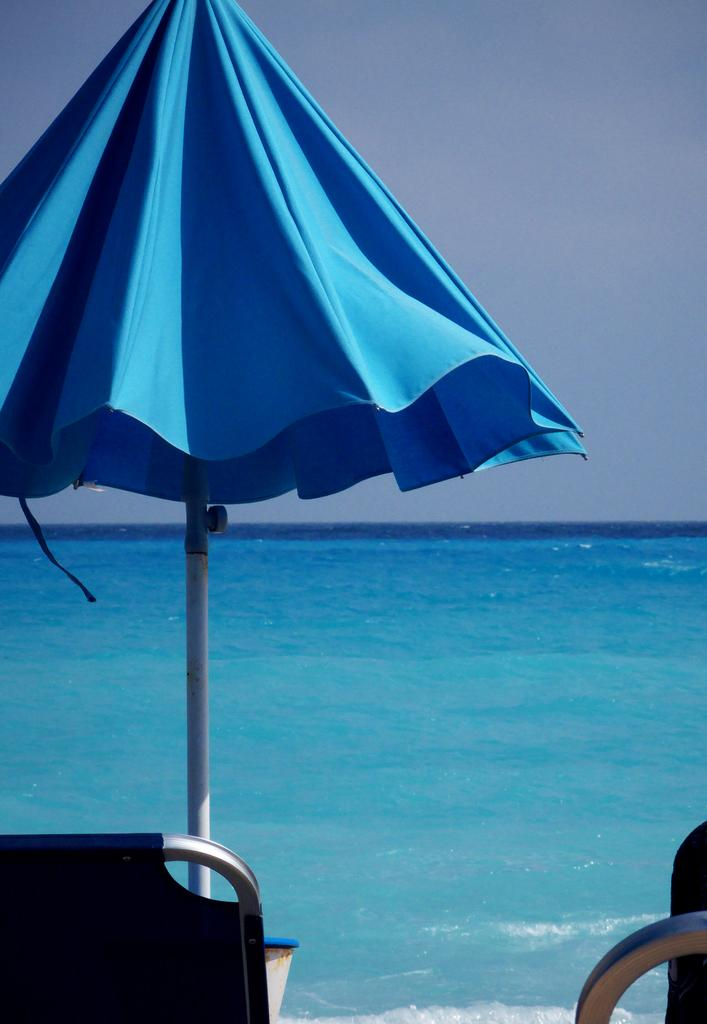What natural feature is present in the image? There is a river in the image. What type of furniture is located beside the river? There is a chair beside the river. What object is arranged near the chair? There is an umbrella arranged in the vicinity of the chair. What type of vacation destination is depicted in the image? The image does not depict a vacation destination; it features a river, a chair, and an umbrella. What type of veil is draped over the chair in the image? There is no veil present in the image; it features a river, a chair, and an umbrella. 